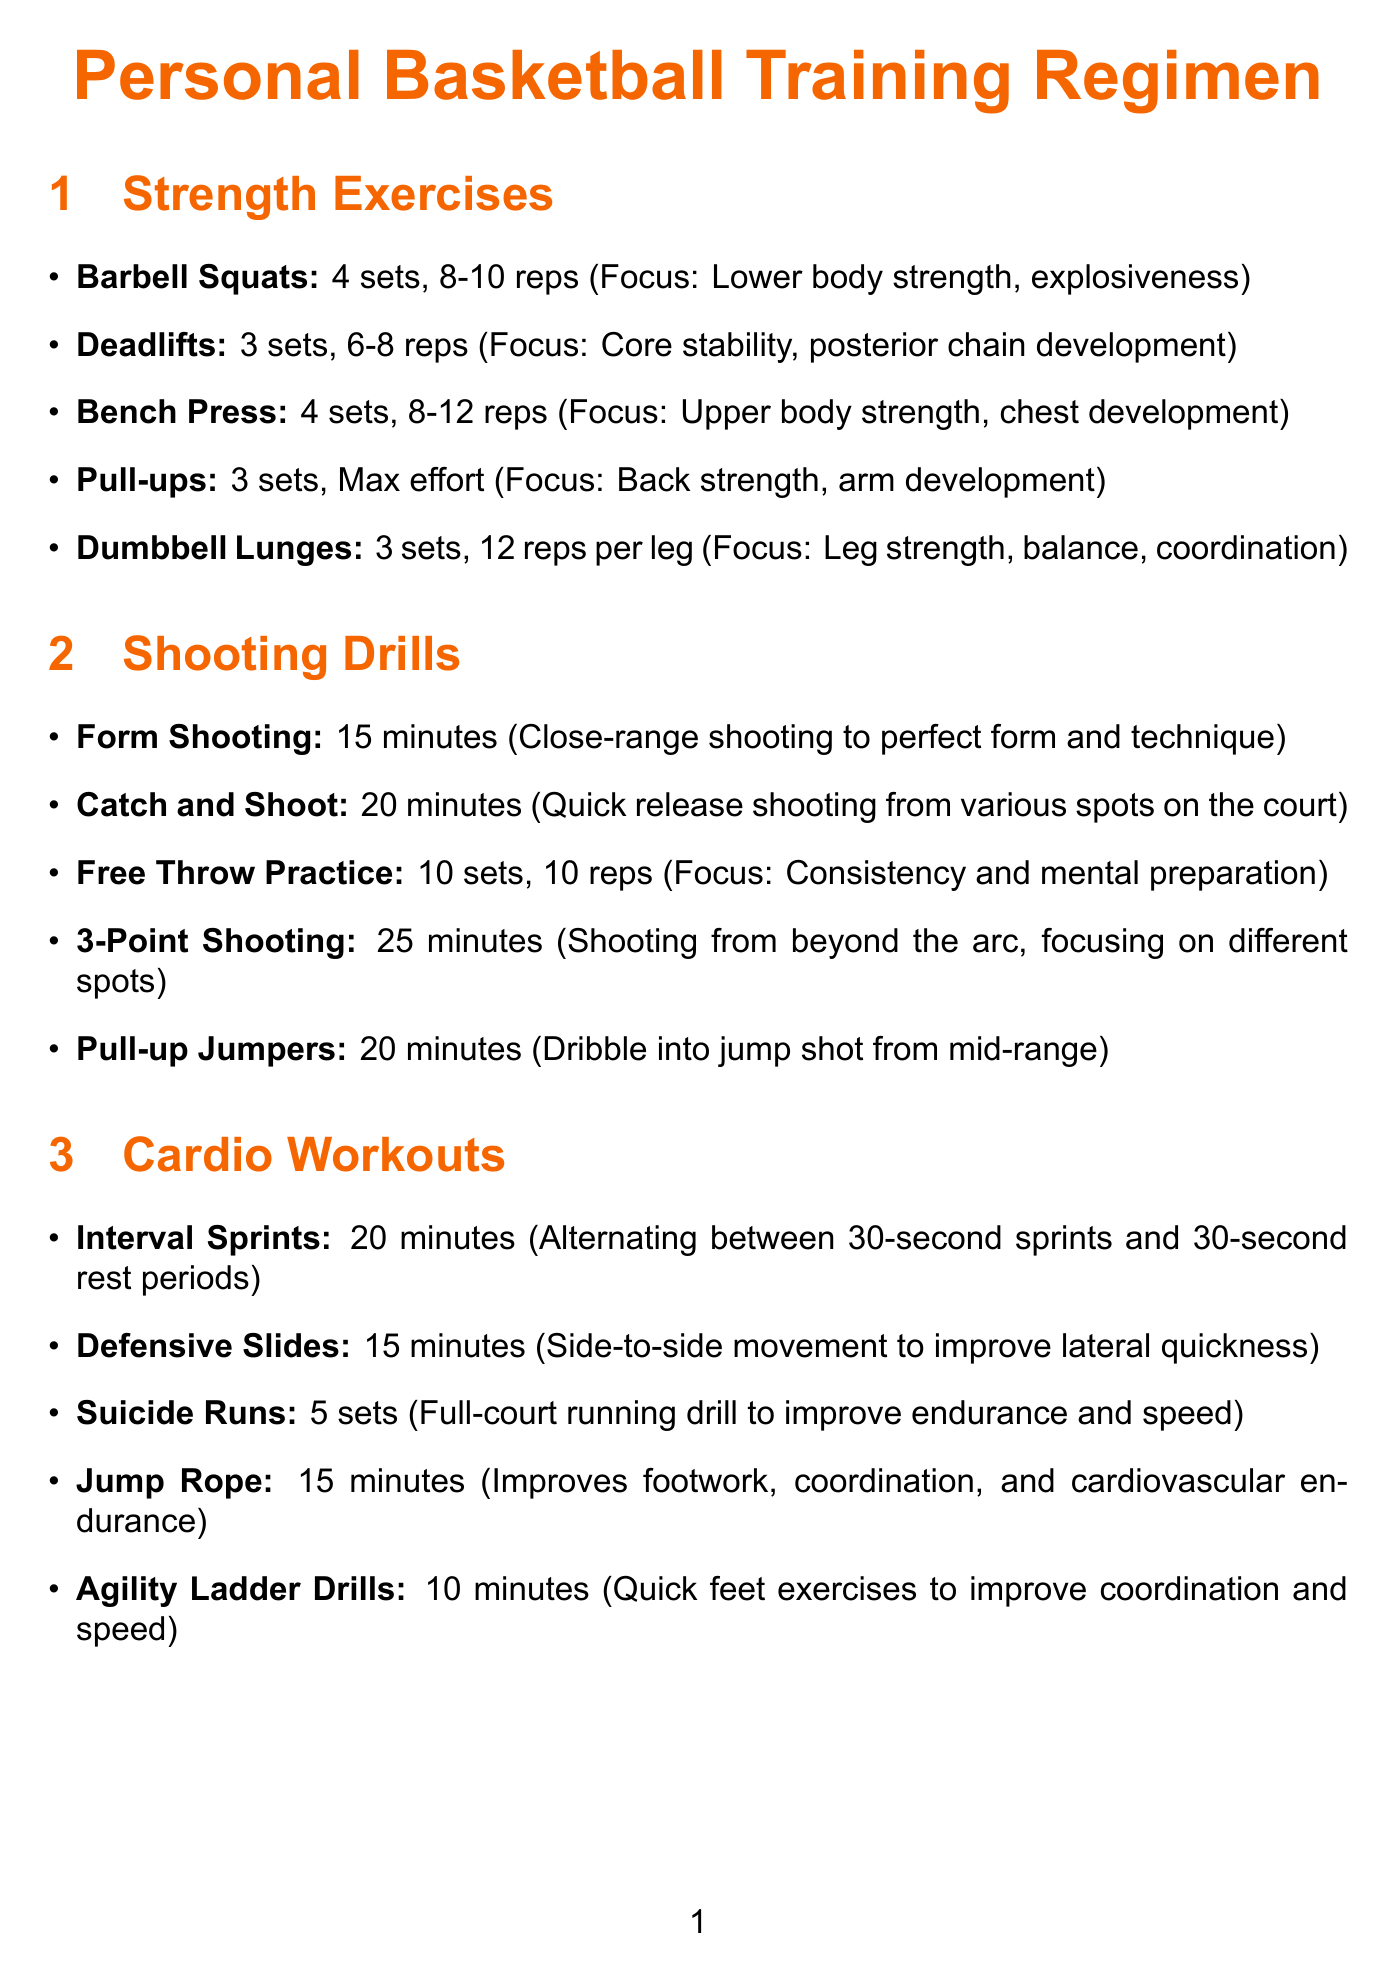What are the three types of personal training exercises? The document includes strength exercises, shooting drills, and cardio workouts.
Answer: Strength exercises, shooting drills, cardio workouts How many sets of Barbell Squats are prescribed? The document lists 4 sets for Barbell Squats under strength exercises.
Answer: 4 sets What is the duration of the 3-Point Shooting drill? The 3-Point Shooting drill is specified to have a duration of 25 minutes in the shooting drills section.
Answer: 25 minutes What is the focus of Dumbbell Lunges? The focus of Dumbbell Lunges is stated as leg strength, balance, and coordination.
Answer: Leg strength, balance, coordination How many days are scheduled for strength training each week? There are three instances of strength training on Monday, Wednesday, and Friday in the weekly schedule.
Answer: 3 days Which recovery method is recommended for muscle tension release? Foam rolling is mentioned as a recovery method for muscle tension release.
Answer: Foam rolling What is the primary focus of Free Throw Practice? The document identifies the consistency and mental preparation as the focus for Free Throw Practice.
Answer: Consistency and mental preparation What type of equipment is used for vertical jump training? The document specifies Vertimax as the equipment for vertical jump training.
Answer: Vertimax What activity is scheduled for Sunday? The schedule indicates active recovery and light shooting practice for Sunday.
Answer: Active recovery, light shooting practice 